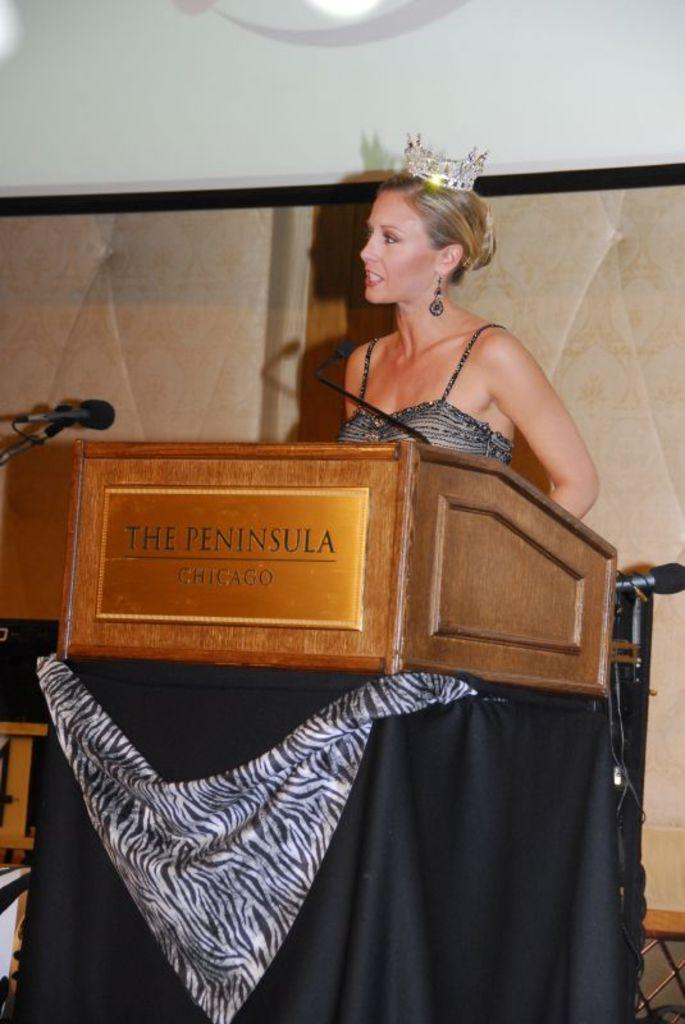Who is present in the image? There is a woman in the image. What is the woman wearing? The woman is wearing clothes, earrings, and a crown. What objects are present in the image related to speaking or presenting? There is a podium and a microphone in the image. What can be seen in the background of the image? There is a background in the image. What type of lighting is present in the image? There is a light in the image. What type of pie is being served on the plate in the image? There is no plate or pie present in the image; it features a woman wearing a crown and holding a microphone. 